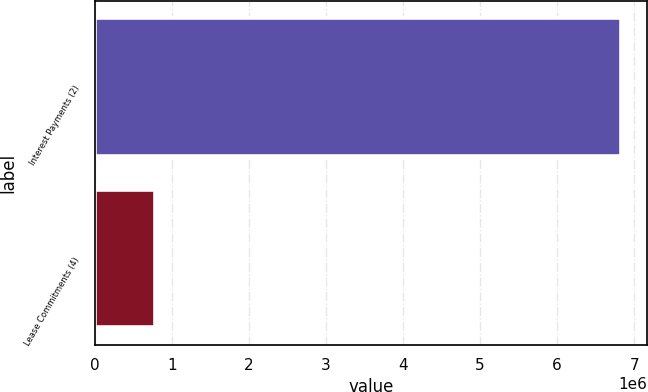Convert chart. <chart><loc_0><loc_0><loc_500><loc_500><bar_chart><fcel>Interest Payments (2)<fcel>Lease Commitments (4)<nl><fcel>6.83232e+06<fcel>780422<nl></chart> 